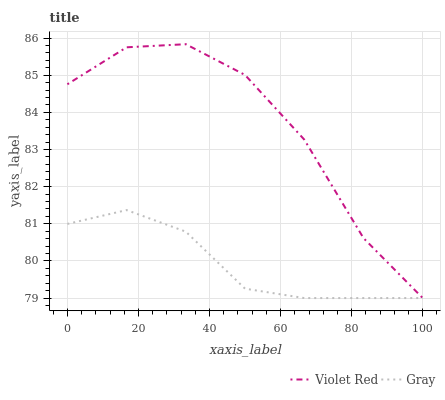Does Gray have the minimum area under the curve?
Answer yes or no. Yes. Does Violet Red have the maximum area under the curve?
Answer yes or no. Yes. Does Violet Red have the minimum area under the curve?
Answer yes or no. No. Is Gray the smoothest?
Answer yes or no. Yes. Is Violet Red the roughest?
Answer yes or no. Yes. Is Violet Red the smoothest?
Answer yes or no. No. Does Gray have the lowest value?
Answer yes or no. Yes. Does Violet Red have the highest value?
Answer yes or no. Yes. Does Gray intersect Violet Red?
Answer yes or no. Yes. Is Gray less than Violet Red?
Answer yes or no. No. Is Gray greater than Violet Red?
Answer yes or no. No. 